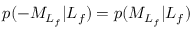Convert formula to latex. <formula><loc_0><loc_0><loc_500><loc_500>p ( - { M } _ { L _ { f } } | L _ { f } ) = p ( { M } _ { L _ { f } } | L _ { f } )</formula> 